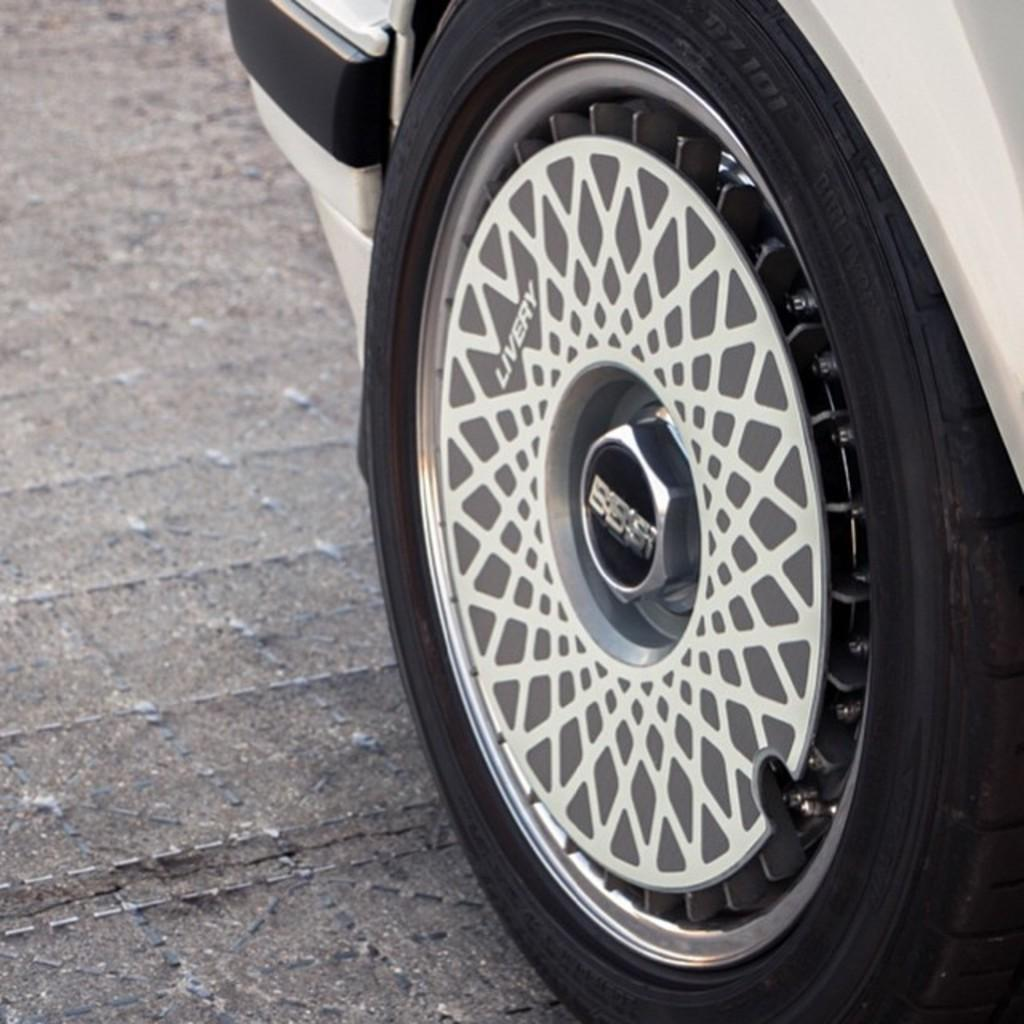What object is the main focus of the image? There is a vehicle tyre in the image. What can be observed about the surface beneath the tyre? The surface beneath the tyre is grey in color. What flavor of pot can be seen in the image? There is no pot present in the image, and therefore no flavor can be determined. 